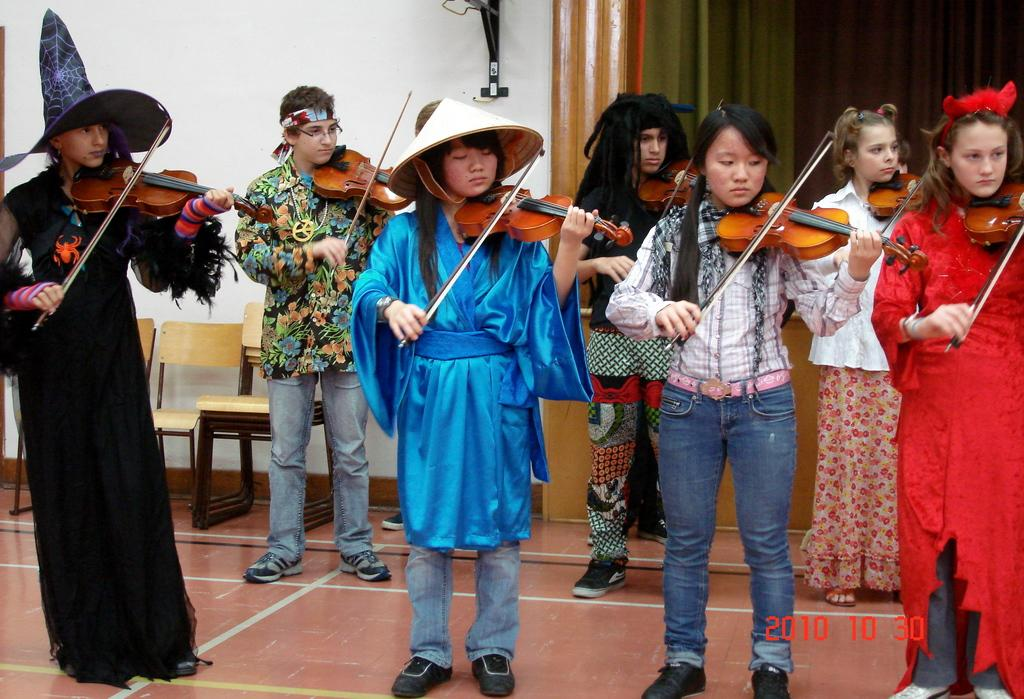How many people are in the image? There is a group of persons in the image. What are the persons in the image doing? The persons are standing and playing violins. What is the coast like in the image? There is no coast present in the image; it features a group of persons playing violins. How does the throat of the person playing the violin look in the image? There is no visible throat of the person playing the violin in the image. 